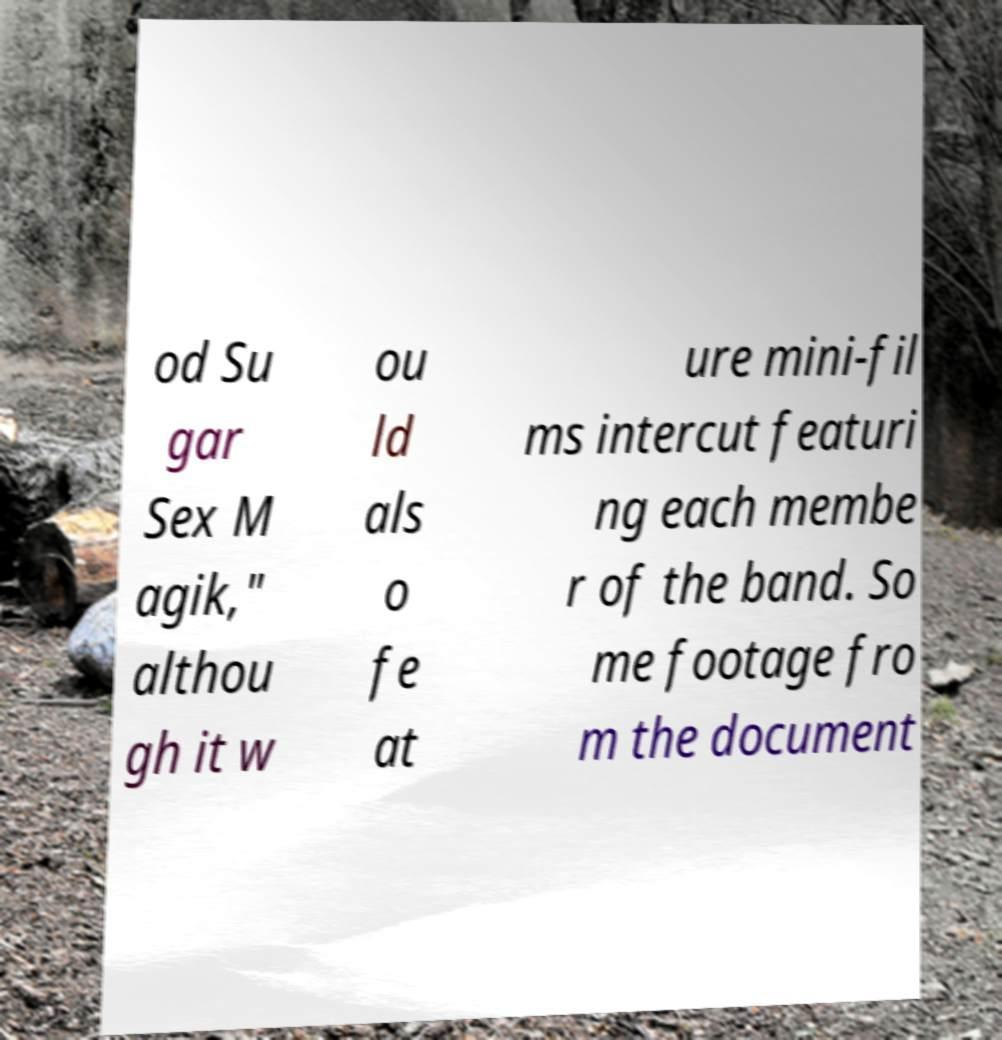What messages or text are displayed in this image? I need them in a readable, typed format. od Su gar Sex M agik," althou gh it w ou ld als o fe at ure mini-fil ms intercut featuri ng each membe r of the band. So me footage fro m the document 